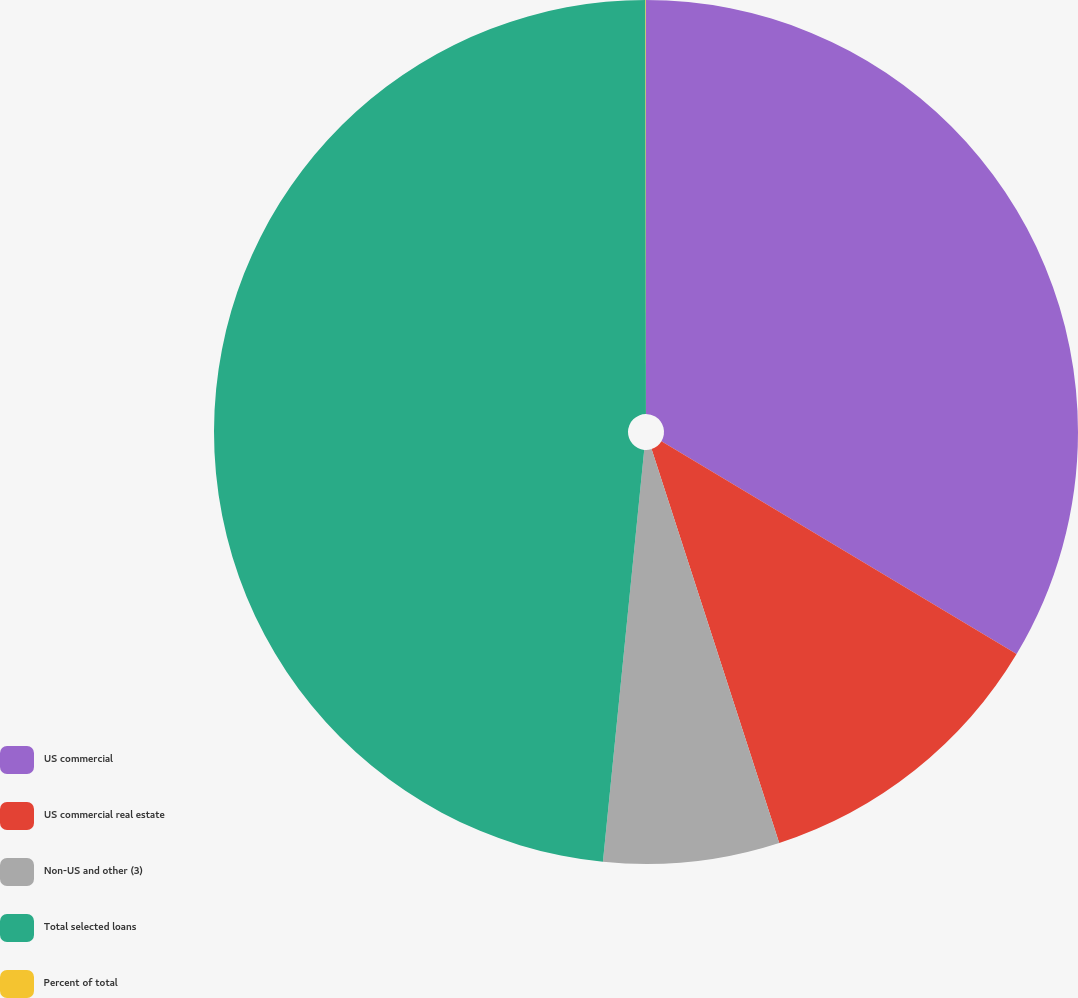Convert chart. <chart><loc_0><loc_0><loc_500><loc_500><pie_chart><fcel>US commercial<fcel>US commercial real estate<fcel>Non-US and other (3)<fcel>Total selected loans<fcel>Percent of total<nl><fcel>33.59%<fcel>11.42%<fcel>6.58%<fcel>48.39%<fcel>0.02%<nl></chart> 